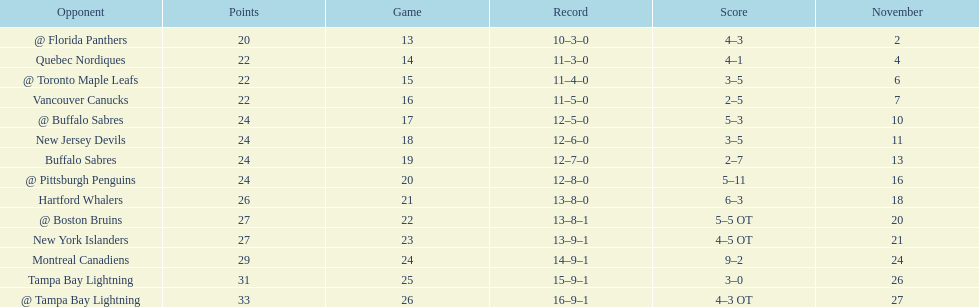The 1993-1994 flyers missed the playoffs again. how many consecutive seasons up until 93-94 did the flyers miss the playoffs? 5. 